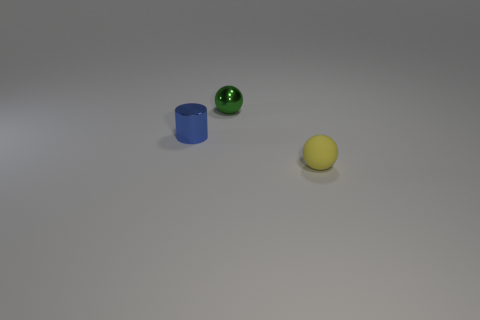Add 1 big yellow metal blocks. How many objects exist? 4 Subtract all cyan spheres. Subtract all brown cubes. How many spheres are left? 2 Subtract all blue blocks. How many gray cylinders are left? 0 Subtract all matte cubes. Subtract all blue cylinders. How many objects are left? 2 Add 1 yellow objects. How many yellow objects are left? 2 Add 3 tiny purple spheres. How many tiny purple spheres exist? 3 Subtract all green balls. How many balls are left? 1 Subtract 0 red cubes. How many objects are left? 3 Subtract all cylinders. How many objects are left? 2 Subtract 2 spheres. How many spheres are left? 0 